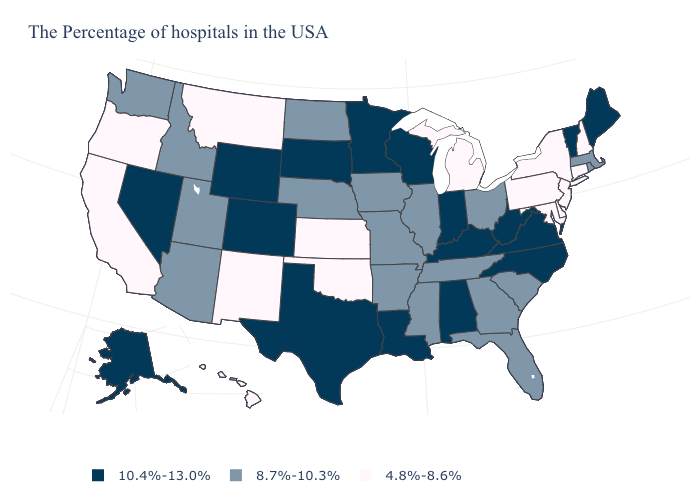Name the states that have a value in the range 4.8%-8.6%?
Give a very brief answer. New Hampshire, Connecticut, New York, New Jersey, Delaware, Maryland, Pennsylvania, Michigan, Kansas, Oklahoma, New Mexico, Montana, California, Oregon, Hawaii. What is the value of Michigan?
Write a very short answer. 4.8%-8.6%. Name the states that have a value in the range 4.8%-8.6%?
Quick response, please. New Hampshire, Connecticut, New York, New Jersey, Delaware, Maryland, Pennsylvania, Michigan, Kansas, Oklahoma, New Mexico, Montana, California, Oregon, Hawaii. What is the lowest value in the MidWest?
Give a very brief answer. 4.8%-8.6%. Name the states that have a value in the range 4.8%-8.6%?
Be succinct. New Hampshire, Connecticut, New York, New Jersey, Delaware, Maryland, Pennsylvania, Michigan, Kansas, Oklahoma, New Mexico, Montana, California, Oregon, Hawaii. Among the states that border South Carolina , does North Carolina have the lowest value?
Concise answer only. No. Does Texas have a lower value than New York?
Keep it brief. No. What is the lowest value in states that border Rhode Island?
Answer briefly. 4.8%-8.6%. Does Maine have the same value as South Dakota?
Quick response, please. Yes. Name the states that have a value in the range 8.7%-10.3%?
Concise answer only. Massachusetts, Rhode Island, South Carolina, Ohio, Florida, Georgia, Tennessee, Illinois, Mississippi, Missouri, Arkansas, Iowa, Nebraska, North Dakota, Utah, Arizona, Idaho, Washington. Does the first symbol in the legend represent the smallest category?
Give a very brief answer. No. Is the legend a continuous bar?
Keep it brief. No. What is the value of Hawaii?
Give a very brief answer. 4.8%-8.6%. What is the value of Utah?
Quick response, please. 8.7%-10.3%. 